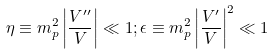<formula> <loc_0><loc_0><loc_500><loc_500>\eta \equiv m _ { p } ^ { 2 } \left | \frac { V ^ { \prime \prime } } { V } \right | \ll 1 ; \epsilon \equiv m _ { p } ^ { 2 } \left | \frac { V ^ { \prime } } { V } \right | ^ { 2 } \ll 1</formula> 